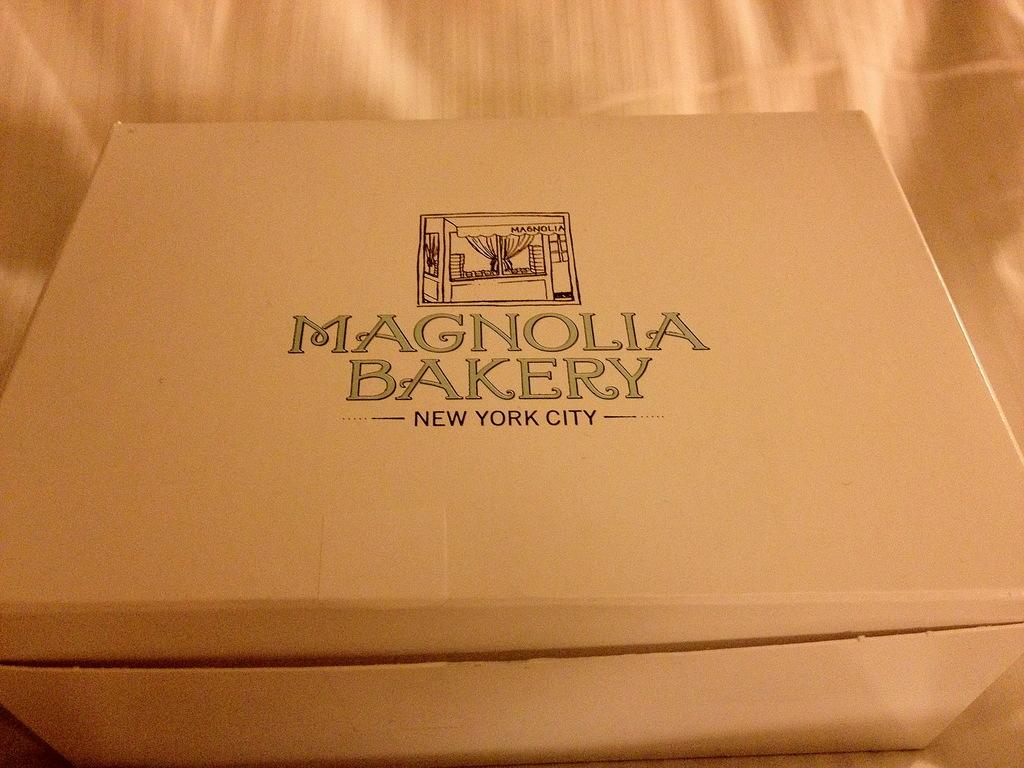<image>
Relay a brief, clear account of the picture shown. A white box from the Magnolia Bakery in New York city 